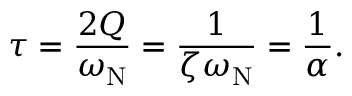Convert formula to latex. <formula><loc_0><loc_0><loc_500><loc_500>\tau = { \frac { 2 Q } { \omega _ { N } } } = { \frac { 1 } { \zeta \omega _ { N } } } = { \frac { 1 } { \alpha } } .</formula> 